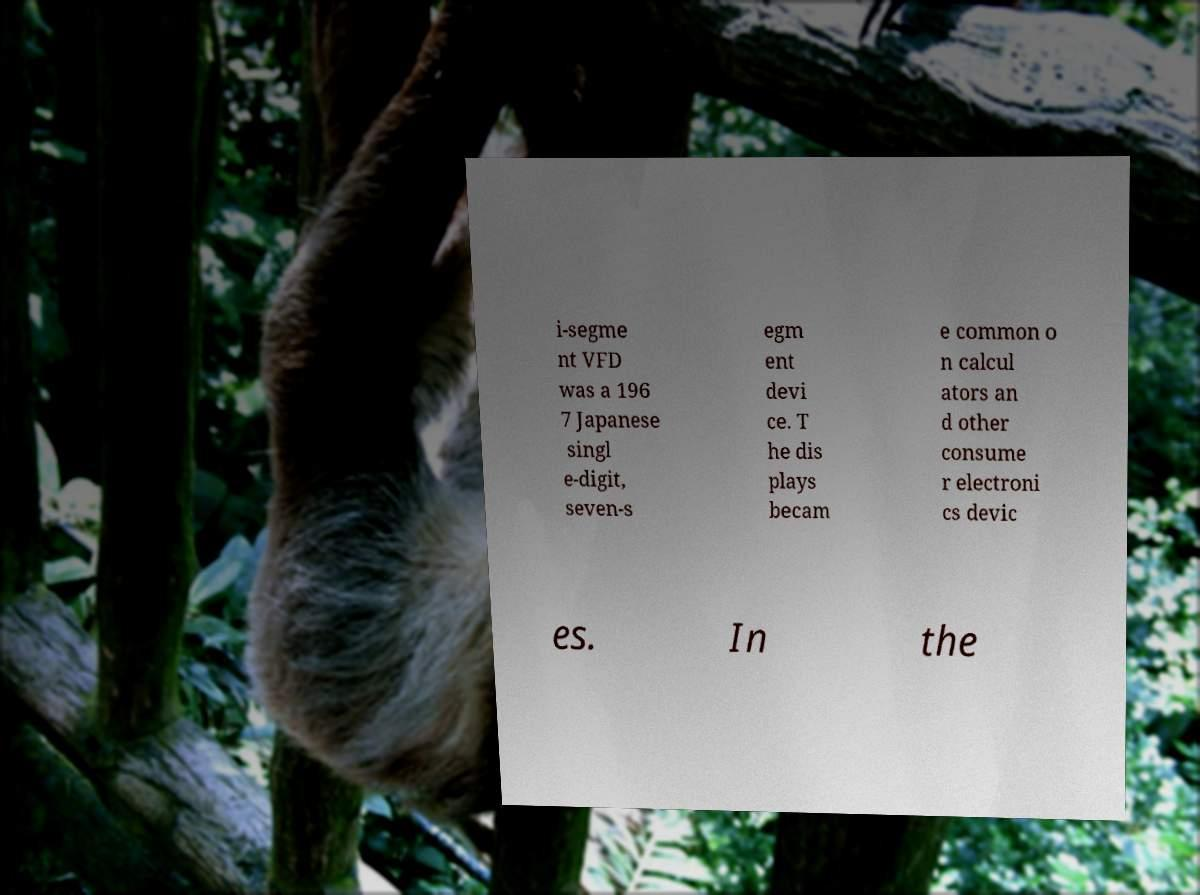I need the written content from this picture converted into text. Can you do that? i-segme nt VFD was a 196 7 Japanese singl e-digit, seven-s egm ent devi ce. T he dis plays becam e common o n calcul ators an d other consume r electroni cs devic es. In the 